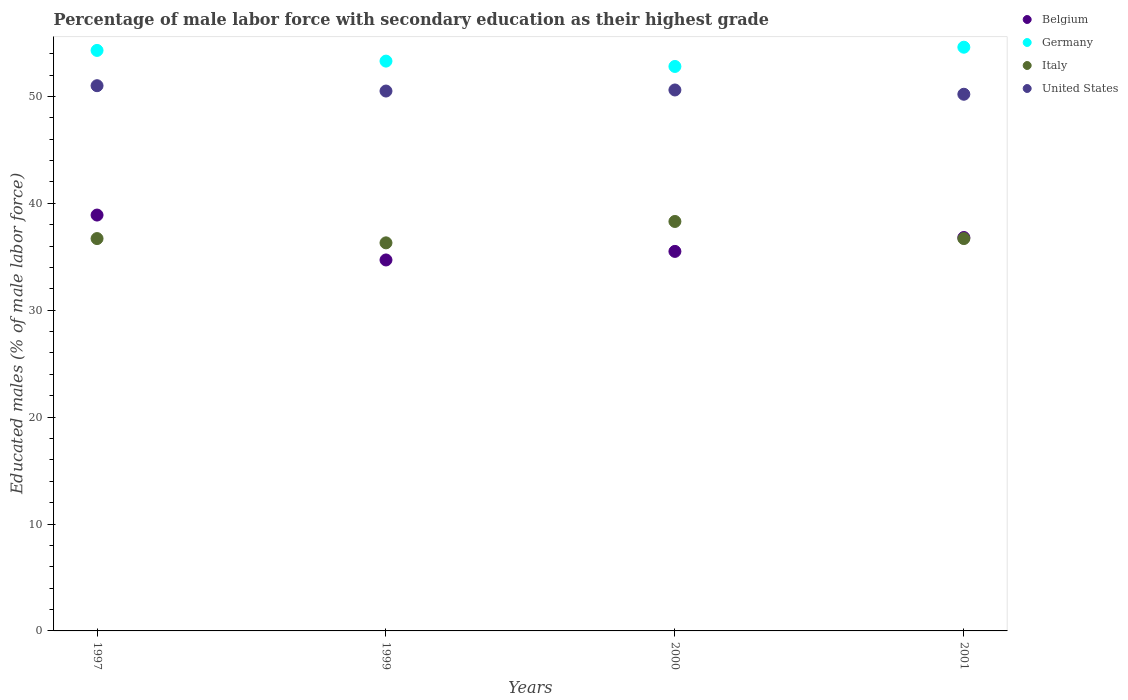How many different coloured dotlines are there?
Keep it short and to the point. 4. Is the number of dotlines equal to the number of legend labels?
Give a very brief answer. Yes. What is the percentage of male labor force with secondary education in Italy in 1997?
Your answer should be compact. 36.7. Across all years, what is the maximum percentage of male labor force with secondary education in Belgium?
Provide a short and direct response. 38.9. Across all years, what is the minimum percentage of male labor force with secondary education in Italy?
Your answer should be compact. 36.3. What is the total percentage of male labor force with secondary education in Germany in the graph?
Give a very brief answer. 215. What is the difference between the percentage of male labor force with secondary education in United States in 1997 and that in 2001?
Ensure brevity in your answer.  0.8. What is the difference between the percentage of male labor force with secondary education in United States in 1997 and the percentage of male labor force with secondary education in Belgium in 2000?
Ensure brevity in your answer.  15.5. What is the average percentage of male labor force with secondary education in United States per year?
Provide a short and direct response. 50.57. In the year 1997, what is the difference between the percentage of male labor force with secondary education in Germany and percentage of male labor force with secondary education in Italy?
Ensure brevity in your answer.  17.6. What is the ratio of the percentage of male labor force with secondary education in Italy in 1997 to that in 2001?
Your answer should be very brief. 1. Is the percentage of male labor force with secondary education in United States in 2000 less than that in 2001?
Ensure brevity in your answer.  No. What is the difference between the highest and the second highest percentage of male labor force with secondary education in United States?
Your answer should be compact. 0.4. What is the difference between the highest and the lowest percentage of male labor force with secondary education in United States?
Your answer should be compact. 0.8. In how many years, is the percentage of male labor force with secondary education in United States greater than the average percentage of male labor force with secondary education in United States taken over all years?
Offer a very short reply. 2. Is it the case that in every year, the sum of the percentage of male labor force with secondary education in United States and percentage of male labor force with secondary education in Italy  is greater than the sum of percentage of male labor force with secondary education in Belgium and percentage of male labor force with secondary education in Germany?
Your answer should be very brief. Yes. Is it the case that in every year, the sum of the percentage of male labor force with secondary education in Italy and percentage of male labor force with secondary education in United States  is greater than the percentage of male labor force with secondary education in Belgium?
Ensure brevity in your answer.  Yes. Is the percentage of male labor force with secondary education in Germany strictly greater than the percentage of male labor force with secondary education in United States over the years?
Your response must be concise. Yes. Is the percentage of male labor force with secondary education in United States strictly less than the percentage of male labor force with secondary education in Belgium over the years?
Keep it short and to the point. No. How many years are there in the graph?
Give a very brief answer. 4. What is the difference between two consecutive major ticks on the Y-axis?
Your answer should be compact. 10. Does the graph contain grids?
Provide a succinct answer. No. How many legend labels are there?
Your answer should be very brief. 4. How are the legend labels stacked?
Ensure brevity in your answer.  Vertical. What is the title of the graph?
Offer a very short reply. Percentage of male labor force with secondary education as their highest grade. What is the label or title of the Y-axis?
Provide a short and direct response. Educated males (% of male labor force). What is the Educated males (% of male labor force) of Belgium in 1997?
Ensure brevity in your answer.  38.9. What is the Educated males (% of male labor force) in Germany in 1997?
Give a very brief answer. 54.3. What is the Educated males (% of male labor force) of Italy in 1997?
Your answer should be compact. 36.7. What is the Educated males (% of male labor force) of United States in 1997?
Your answer should be very brief. 51. What is the Educated males (% of male labor force) of Belgium in 1999?
Provide a short and direct response. 34.7. What is the Educated males (% of male labor force) of Germany in 1999?
Keep it short and to the point. 53.3. What is the Educated males (% of male labor force) of Italy in 1999?
Offer a terse response. 36.3. What is the Educated males (% of male labor force) of United States in 1999?
Ensure brevity in your answer.  50.5. What is the Educated males (% of male labor force) in Belgium in 2000?
Give a very brief answer. 35.5. What is the Educated males (% of male labor force) in Germany in 2000?
Your answer should be compact. 52.8. What is the Educated males (% of male labor force) of Italy in 2000?
Your answer should be very brief. 38.3. What is the Educated males (% of male labor force) of United States in 2000?
Offer a terse response. 50.6. What is the Educated males (% of male labor force) in Belgium in 2001?
Make the answer very short. 36.8. What is the Educated males (% of male labor force) in Germany in 2001?
Give a very brief answer. 54.6. What is the Educated males (% of male labor force) of Italy in 2001?
Give a very brief answer. 36.7. What is the Educated males (% of male labor force) of United States in 2001?
Provide a succinct answer. 50.2. Across all years, what is the maximum Educated males (% of male labor force) in Belgium?
Your answer should be compact. 38.9. Across all years, what is the maximum Educated males (% of male labor force) in Germany?
Keep it short and to the point. 54.6. Across all years, what is the maximum Educated males (% of male labor force) of Italy?
Make the answer very short. 38.3. Across all years, what is the maximum Educated males (% of male labor force) in United States?
Your answer should be very brief. 51. Across all years, what is the minimum Educated males (% of male labor force) in Belgium?
Make the answer very short. 34.7. Across all years, what is the minimum Educated males (% of male labor force) in Germany?
Your response must be concise. 52.8. Across all years, what is the minimum Educated males (% of male labor force) in Italy?
Provide a short and direct response. 36.3. Across all years, what is the minimum Educated males (% of male labor force) of United States?
Your answer should be compact. 50.2. What is the total Educated males (% of male labor force) in Belgium in the graph?
Provide a succinct answer. 145.9. What is the total Educated males (% of male labor force) in Germany in the graph?
Make the answer very short. 215. What is the total Educated males (% of male labor force) in Italy in the graph?
Make the answer very short. 148. What is the total Educated males (% of male labor force) of United States in the graph?
Ensure brevity in your answer.  202.3. What is the difference between the Educated males (% of male labor force) in Belgium in 1997 and that in 2000?
Give a very brief answer. 3.4. What is the difference between the Educated males (% of male labor force) of Germany in 1997 and that in 2001?
Your response must be concise. -0.3. What is the difference between the Educated males (% of male labor force) in Belgium in 1999 and that in 2000?
Keep it short and to the point. -0.8. What is the difference between the Educated males (% of male labor force) in Italy in 1999 and that in 2000?
Offer a terse response. -2. What is the difference between the Educated males (% of male labor force) of Belgium in 1999 and that in 2001?
Give a very brief answer. -2.1. What is the difference between the Educated males (% of male labor force) of United States in 1999 and that in 2001?
Make the answer very short. 0.3. What is the difference between the Educated males (% of male labor force) of Belgium in 2000 and that in 2001?
Your answer should be very brief. -1.3. What is the difference between the Educated males (% of male labor force) of Germany in 2000 and that in 2001?
Offer a terse response. -1.8. What is the difference between the Educated males (% of male labor force) of Italy in 2000 and that in 2001?
Give a very brief answer. 1.6. What is the difference between the Educated males (% of male labor force) in Belgium in 1997 and the Educated males (% of male labor force) in Germany in 1999?
Give a very brief answer. -14.4. What is the difference between the Educated males (% of male labor force) of Belgium in 1997 and the Educated males (% of male labor force) of Italy in 1999?
Ensure brevity in your answer.  2.6. What is the difference between the Educated males (% of male labor force) of Germany in 1997 and the Educated males (% of male labor force) of Italy in 1999?
Provide a succinct answer. 18. What is the difference between the Educated males (% of male labor force) in Belgium in 1997 and the Educated males (% of male labor force) in United States in 2000?
Provide a short and direct response. -11.7. What is the difference between the Educated males (% of male labor force) of Germany in 1997 and the Educated males (% of male labor force) of Italy in 2000?
Keep it short and to the point. 16. What is the difference between the Educated males (% of male labor force) of Belgium in 1997 and the Educated males (% of male labor force) of Germany in 2001?
Offer a terse response. -15.7. What is the difference between the Educated males (% of male labor force) of Belgium in 1999 and the Educated males (% of male labor force) of Germany in 2000?
Your response must be concise. -18.1. What is the difference between the Educated males (% of male labor force) of Belgium in 1999 and the Educated males (% of male labor force) of Italy in 2000?
Keep it short and to the point. -3.6. What is the difference between the Educated males (% of male labor force) in Belgium in 1999 and the Educated males (% of male labor force) in United States in 2000?
Ensure brevity in your answer.  -15.9. What is the difference between the Educated males (% of male labor force) in Germany in 1999 and the Educated males (% of male labor force) in Italy in 2000?
Keep it short and to the point. 15. What is the difference between the Educated males (% of male labor force) of Germany in 1999 and the Educated males (% of male labor force) of United States in 2000?
Your response must be concise. 2.7. What is the difference between the Educated males (% of male labor force) of Italy in 1999 and the Educated males (% of male labor force) of United States in 2000?
Provide a short and direct response. -14.3. What is the difference between the Educated males (% of male labor force) in Belgium in 1999 and the Educated males (% of male labor force) in Germany in 2001?
Ensure brevity in your answer.  -19.9. What is the difference between the Educated males (% of male labor force) of Belgium in 1999 and the Educated males (% of male labor force) of Italy in 2001?
Give a very brief answer. -2. What is the difference between the Educated males (% of male labor force) of Belgium in 1999 and the Educated males (% of male labor force) of United States in 2001?
Offer a very short reply. -15.5. What is the difference between the Educated males (% of male labor force) in Germany in 1999 and the Educated males (% of male labor force) in United States in 2001?
Your answer should be very brief. 3.1. What is the difference between the Educated males (% of male labor force) of Belgium in 2000 and the Educated males (% of male labor force) of Germany in 2001?
Your response must be concise. -19.1. What is the difference between the Educated males (% of male labor force) of Belgium in 2000 and the Educated males (% of male labor force) of Italy in 2001?
Your response must be concise. -1.2. What is the difference between the Educated males (% of male labor force) of Belgium in 2000 and the Educated males (% of male labor force) of United States in 2001?
Your response must be concise. -14.7. What is the difference between the Educated males (% of male labor force) in Germany in 2000 and the Educated males (% of male labor force) in Italy in 2001?
Provide a succinct answer. 16.1. What is the difference between the Educated males (% of male labor force) in Italy in 2000 and the Educated males (% of male labor force) in United States in 2001?
Your answer should be very brief. -11.9. What is the average Educated males (% of male labor force) in Belgium per year?
Provide a short and direct response. 36.48. What is the average Educated males (% of male labor force) of Germany per year?
Provide a succinct answer. 53.75. What is the average Educated males (% of male labor force) in Italy per year?
Your response must be concise. 37. What is the average Educated males (% of male labor force) in United States per year?
Make the answer very short. 50.58. In the year 1997, what is the difference between the Educated males (% of male labor force) in Belgium and Educated males (% of male labor force) in Germany?
Give a very brief answer. -15.4. In the year 1997, what is the difference between the Educated males (% of male labor force) of Italy and Educated males (% of male labor force) of United States?
Provide a succinct answer. -14.3. In the year 1999, what is the difference between the Educated males (% of male labor force) in Belgium and Educated males (% of male labor force) in Germany?
Give a very brief answer. -18.6. In the year 1999, what is the difference between the Educated males (% of male labor force) of Belgium and Educated males (% of male labor force) of Italy?
Keep it short and to the point. -1.6. In the year 1999, what is the difference between the Educated males (% of male labor force) of Belgium and Educated males (% of male labor force) of United States?
Your answer should be very brief. -15.8. In the year 2000, what is the difference between the Educated males (% of male labor force) of Belgium and Educated males (% of male labor force) of Germany?
Make the answer very short. -17.3. In the year 2000, what is the difference between the Educated males (% of male labor force) in Belgium and Educated males (% of male labor force) in United States?
Your answer should be compact. -15.1. In the year 2000, what is the difference between the Educated males (% of male labor force) of Germany and Educated males (% of male labor force) of Italy?
Offer a terse response. 14.5. In the year 2000, what is the difference between the Educated males (% of male labor force) of Germany and Educated males (% of male labor force) of United States?
Keep it short and to the point. 2.2. In the year 2001, what is the difference between the Educated males (% of male labor force) in Belgium and Educated males (% of male labor force) in Germany?
Provide a short and direct response. -17.8. In the year 2001, what is the difference between the Educated males (% of male labor force) of Belgium and Educated males (% of male labor force) of Italy?
Offer a terse response. 0.1. What is the ratio of the Educated males (% of male labor force) of Belgium in 1997 to that in 1999?
Your answer should be compact. 1.12. What is the ratio of the Educated males (% of male labor force) of Germany in 1997 to that in 1999?
Offer a very short reply. 1.02. What is the ratio of the Educated males (% of male labor force) of Italy in 1997 to that in 1999?
Your answer should be very brief. 1.01. What is the ratio of the Educated males (% of male labor force) of United States in 1997 to that in 1999?
Make the answer very short. 1.01. What is the ratio of the Educated males (% of male labor force) in Belgium in 1997 to that in 2000?
Offer a very short reply. 1.1. What is the ratio of the Educated males (% of male labor force) of Germany in 1997 to that in 2000?
Offer a terse response. 1.03. What is the ratio of the Educated males (% of male labor force) in Italy in 1997 to that in 2000?
Keep it short and to the point. 0.96. What is the ratio of the Educated males (% of male labor force) of United States in 1997 to that in 2000?
Give a very brief answer. 1.01. What is the ratio of the Educated males (% of male labor force) in Belgium in 1997 to that in 2001?
Offer a terse response. 1.06. What is the ratio of the Educated males (% of male labor force) of Germany in 1997 to that in 2001?
Your answer should be compact. 0.99. What is the ratio of the Educated males (% of male labor force) of United States in 1997 to that in 2001?
Offer a very short reply. 1.02. What is the ratio of the Educated males (% of male labor force) of Belgium in 1999 to that in 2000?
Your answer should be very brief. 0.98. What is the ratio of the Educated males (% of male labor force) of Germany in 1999 to that in 2000?
Offer a terse response. 1.01. What is the ratio of the Educated males (% of male labor force) in Italy in 1999 to that in 2000?
Offer a very short reply. 0.95. What is the ratio of the Educated males (% of male labor force) in United States in 1999 to that in 2000?
Make the answer very short. 1. What is the ratio of the Educated males (% of male labor force) in Belgium in 1999 to that in 2001?
Your answer should be very brief. 0.94. What is the ratio of the Educated males (% of male labor force) in Germany in 1999 to that in 2001?
Your response must be concise. 0.98. What is the ratio of the Educated males (% of male labor force) in Belgium in 2000 to that in 2001?
Provide a short and direct response. 0.96. What is the ratio of the Educated males (% of male labor force) in Germany in 2000 to that in 2001?
Make the answer very short. 0.97. What is the ratio of the Educated males (% of male labor force) in Italy in 2000 to that in 2001?
Your answer should be compact. 1.04. What is the ratio of the Educated males (% of male labor force) of United States in 2000 to that in 2001?
Make the answer very short. 1.01. What is the difference between the highest and the second highest Educated males (% of male labor force) in Belgium?
Provide a succinct answer. 2.1. What is the difference between the highest and the second highest Educated males (% of male labor force) in Germany?
Keep it short and to the point. 0.3. What is the difference between the highest and the lowest Educated males (% of male labor force) of Germany?
Provide a succinct answer. 1.8. What is the difference between the highest and the lowest Educated males (% of male labor force) in United States?
Provide a short and direct response. 0.8. 